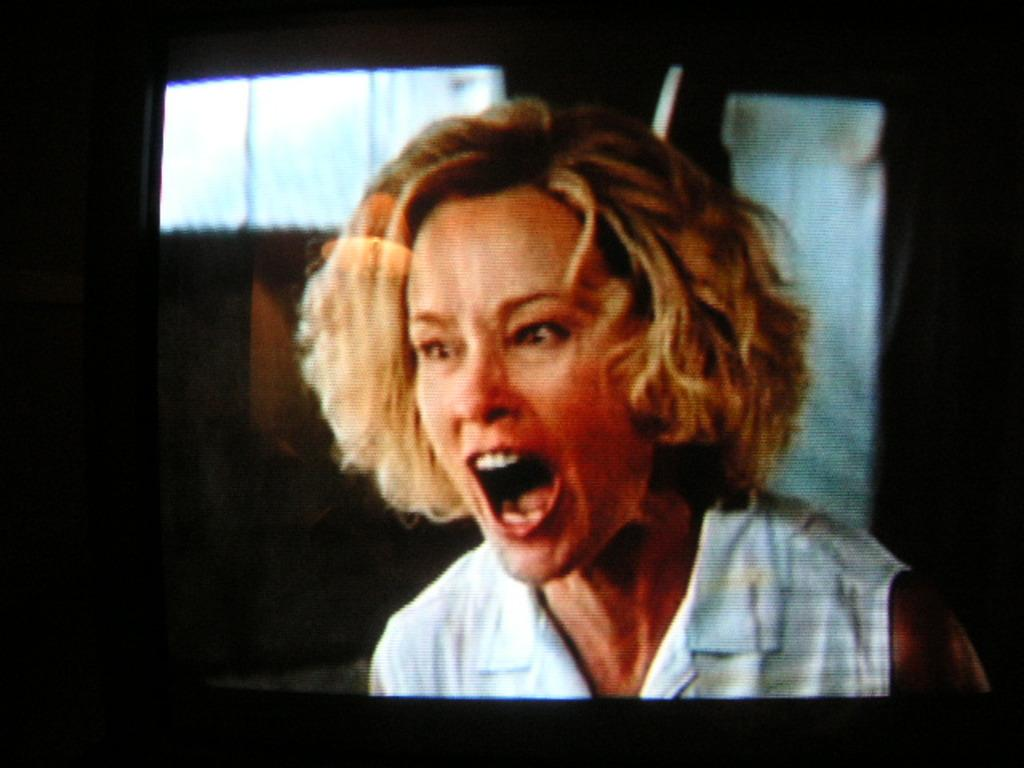What is the main object in the image? There is a screen in the image. What can be seen on the screen? A person wearing a white dress is visible on the screen. What is visible in the background of the image? There is a window in the background of the image. How much income does the person in the white dress earn per year? There is no information about the person's income in the image. 